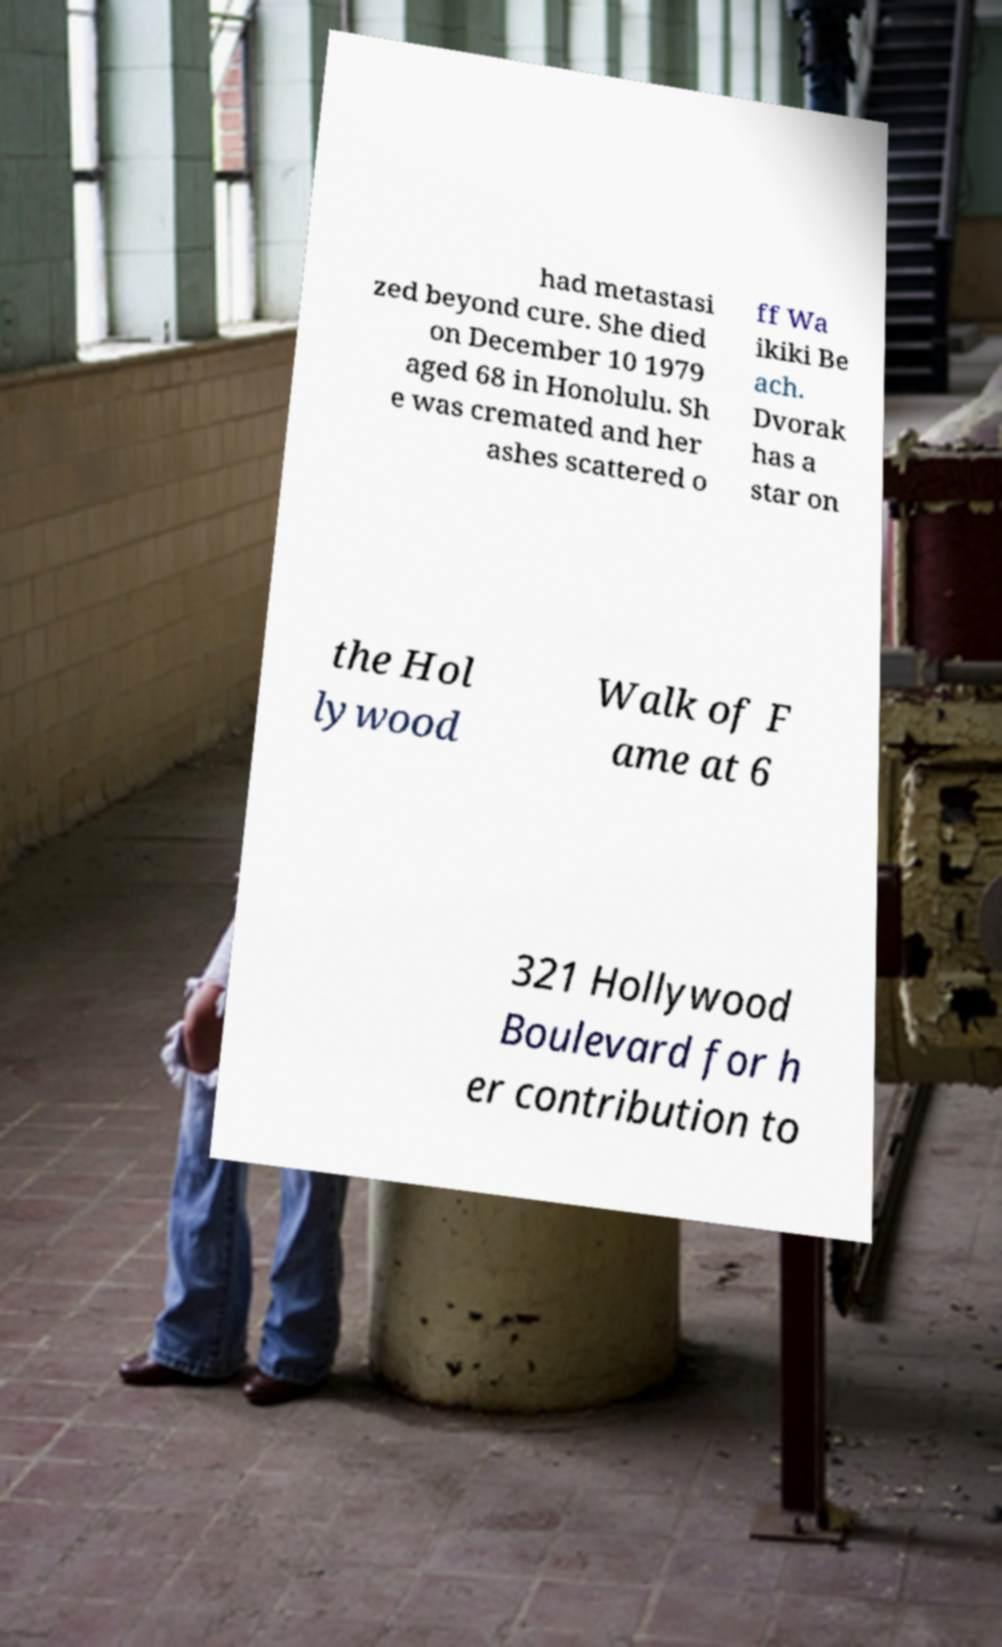Could you assist in decoding the text presented in this image and type it out clearly? had metastasi zed beyond cure. She died on December 10 1979 aged 68 in Honolulu. Sh e was cremated and her ashes scattered o ff Wa ikiki Be ach. Dvorak has a star on the Hol lywood Walk of F ame at 6 321 Hollywood Boulevard for h er contribution to 